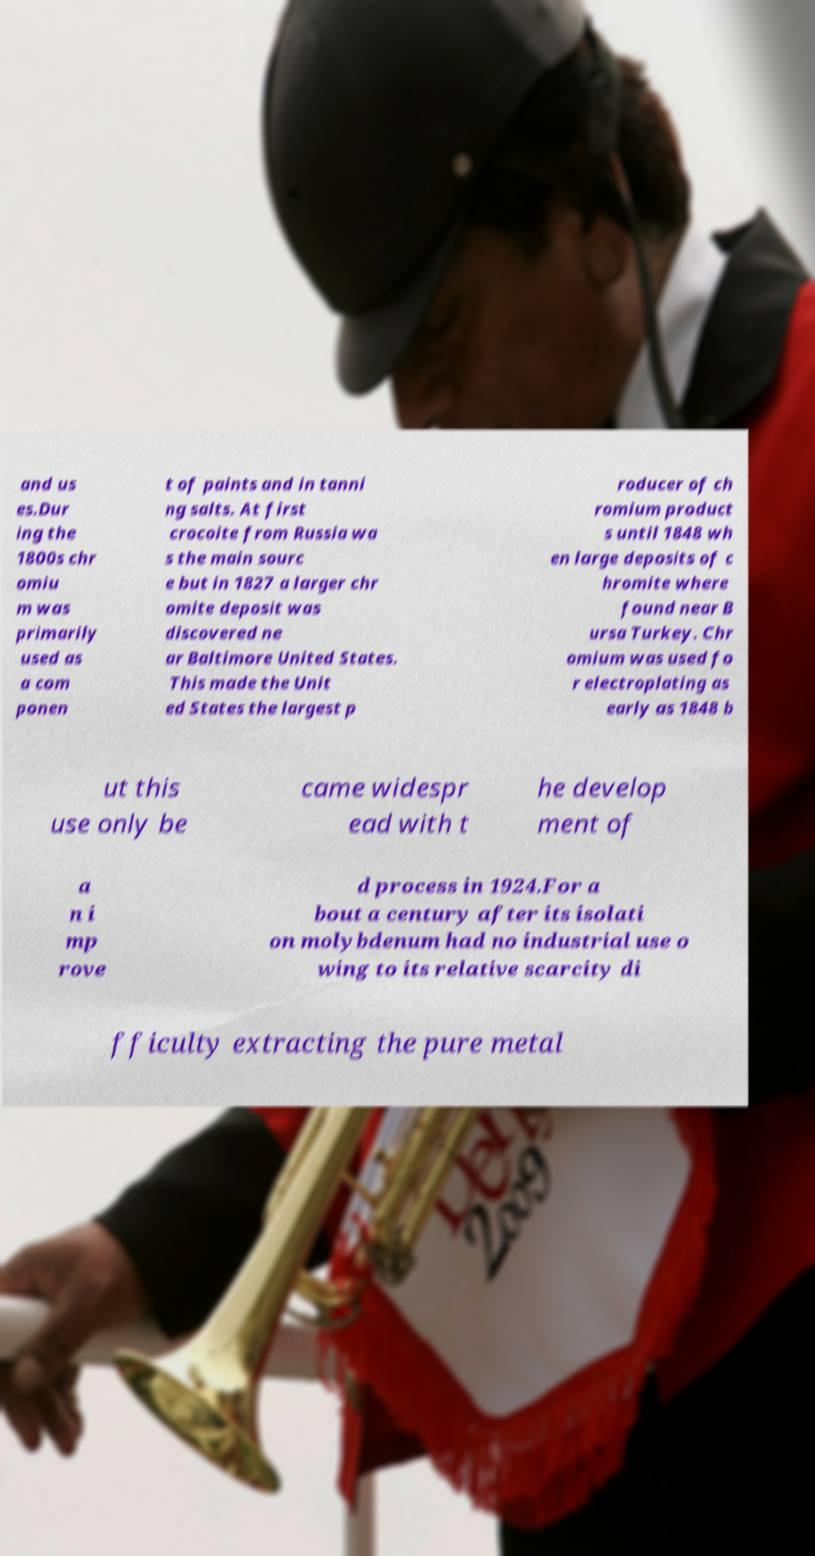For documentation purposes, I need the text within this image transcribed. Could you provide that? and us es.Dur ing the 1800s chr omiu m was primarily used as a com ponen t of paints and in tanni ng salts. At first crocoite from Russia wa s the main sourc e but in 1827 a larger chr omite deposit was discovered ne ar Baltimore United States. This made the Unit ed States the largest p roducer of ch romium product s until 1848 wh en large deposits of c hromite where found near B ursa Turkey. Chr omium was used fo r electroplating as early as 1848 b ut this use only be came widespr ead with t he develop ment of a n i mp rove d process in 1924.For a bout a century after its isolati on molybdenum had no industrial use o wing to its relative scarcity di fficulty extracting the pure metal 